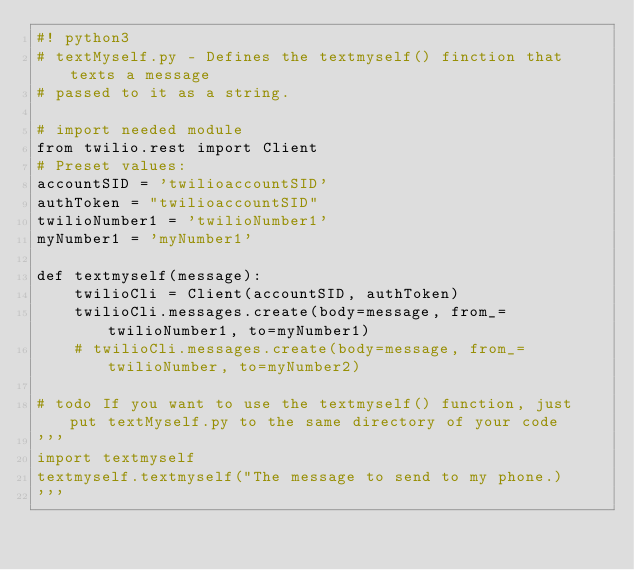Convert code to text. <code><loc_0><loc_0><loc_500><loc_500><_Python_>#! python3
# textMyself.py - Defines the textmyself() finction that texts a message
# passed to it as a string.

# import needed module
from twilio.rest import Client
# Preset values:
accountSID = 'twilioaccountSID'
authToken = "twilioaccountSID"
twilioNumber1 = 'twilioNumber1'
myNumber1 = 'myNumber1'

def textmyself(message):
    twilioCli = Client(accountSID, authToken)
    twilioCli.messages.create(body=message, from_=twilioNumber1, to=myNumber1)
    # twilioCli.messages.create(body=message, from_=twilioNumber, to=myNumber2)

# todo If you want to use the textmyself() function, just put textMyself.py to the same directory of your code
'''
import textmyself
textmyself.textmyself("The message to send to my phone.)
'''
</code> 